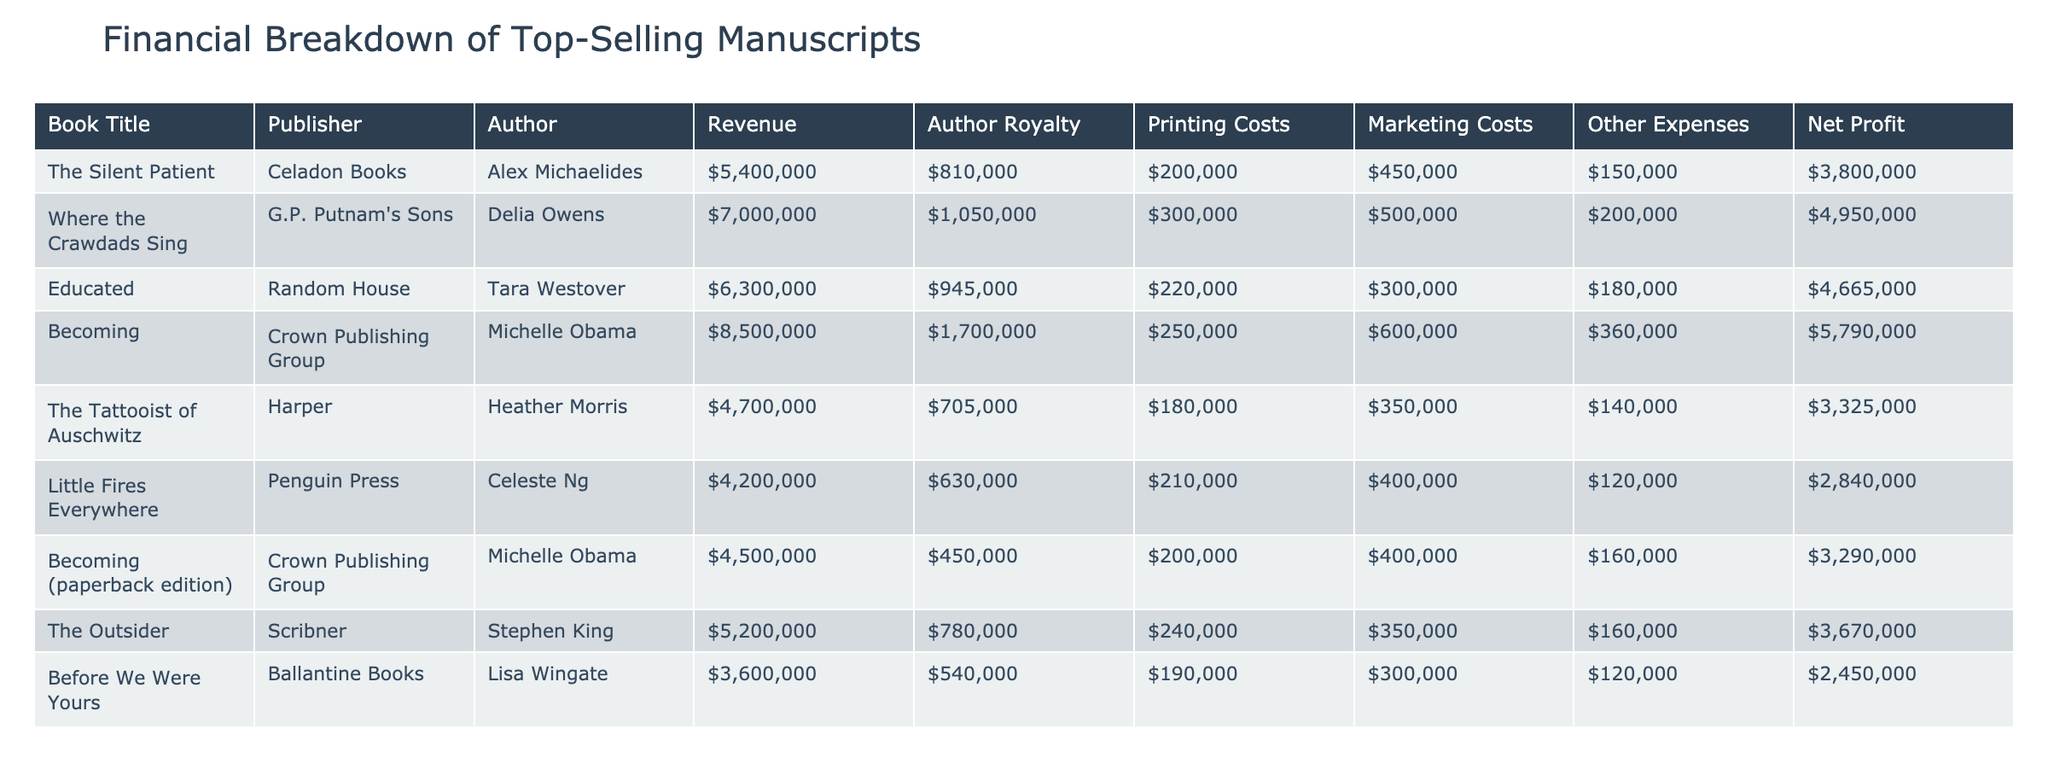What is the revenue of "Where the Crawdads Sing"? The table shows that the revenue for "Where the Crawdads Sing" is listed under the Revenue column. Looking directly at that row, the value is $7,000,000.
Answer: $7,000,000 Which book had the highest net profit? To find the highest net profit, I can compare the values in the Net Profit column. "Becoming" has the highest value at $5,790,000, which is greater than the net profits of the other books.
Answer: $5,790,000 What is the total author royalty payment for all books? The author royalties can be summed up by adding the individual author royalty values: (810,000 + 1,050,000 + 945,000 + 1,700,000 + 705,000 + 630,000 + 450,000 + 780,000 + 540,000) which equals $6,710,000.
Answer: $6,710,000 Did "Little Fires Everywhere" have higher printing costs than "Before We Were Yours"? The printing costs for "Little Fires Everywhere" are $210,000 and for "Before We Were Yours," they are $190,000. Since $210,000 is greater than $190,000, the statement is true.
Answer: Yes What is the average net profit for the two books with the least revenue? First, identify the books with the least revenue, which are "Before We Were Yours" with $3,600,000 and "Little Fires Everywhere" with $4,200,000. Their respective net profits are $2,450,000 and $2,840,000. The average net profit is calculated as (2,450,000 + 2,840,000) / 2 = $2,645,000.
Answer: $2,645,000 Who is the author of the book with the lowest marketing costs? Reviewing the Marketing Costs column, I notice that "Before We Were Yours" has the lowest marketing costs of $300,000. The author of this book is Lisa Wingate.
Answer: Lisa Wingate How much higher were the printing costs for "Educated" compared to "The Tattooist of Auschwitz"? The printing costs for "Educated" are $220,000 and for "The Tattooist of Auschwitz", they are $180,000. To find the difference, subtract the latter from the former: $220,000 - $180,000 = $40,000.
Answer: $40,000 What percentage of the revenue is the author royalty for "The Outsider"? For "The Outsider," the royalty is $780,000, and the revenue is $5,200,000. To find the percentage, I calculate ($780,000 / $5,200,000) * 100 = 15%.
Answer: 15% Is the total revenue for the two editions of "Becoming" greater than the revenue of "The Outsider"? The total revenue for both editions of "Becoming" is $8,500,000 ($8,500,000 for the hardcover and $4,500,000 for the paperback). The revenue for "The Outsider" is $5,200,000. Since $8,500,000 is greater than $5,200,000, the statement is true.
Answer: Yes 